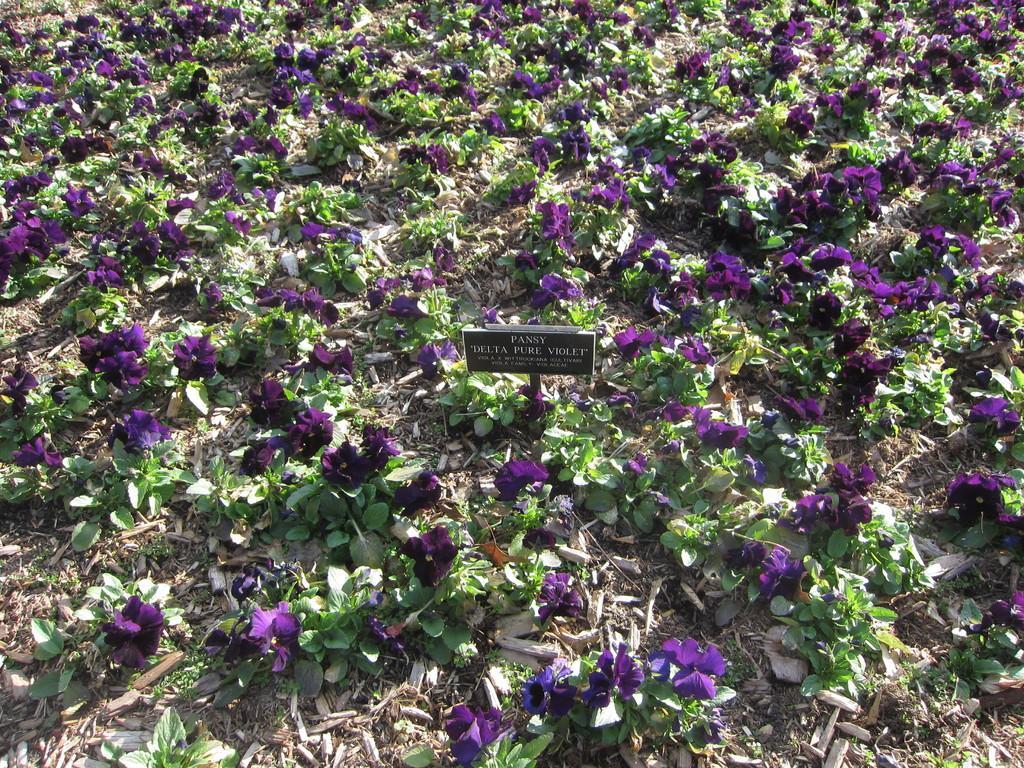In one or two sentences, can you explain what this image depicts? In this image there are flowers, plants and dry leaves on the surface. 